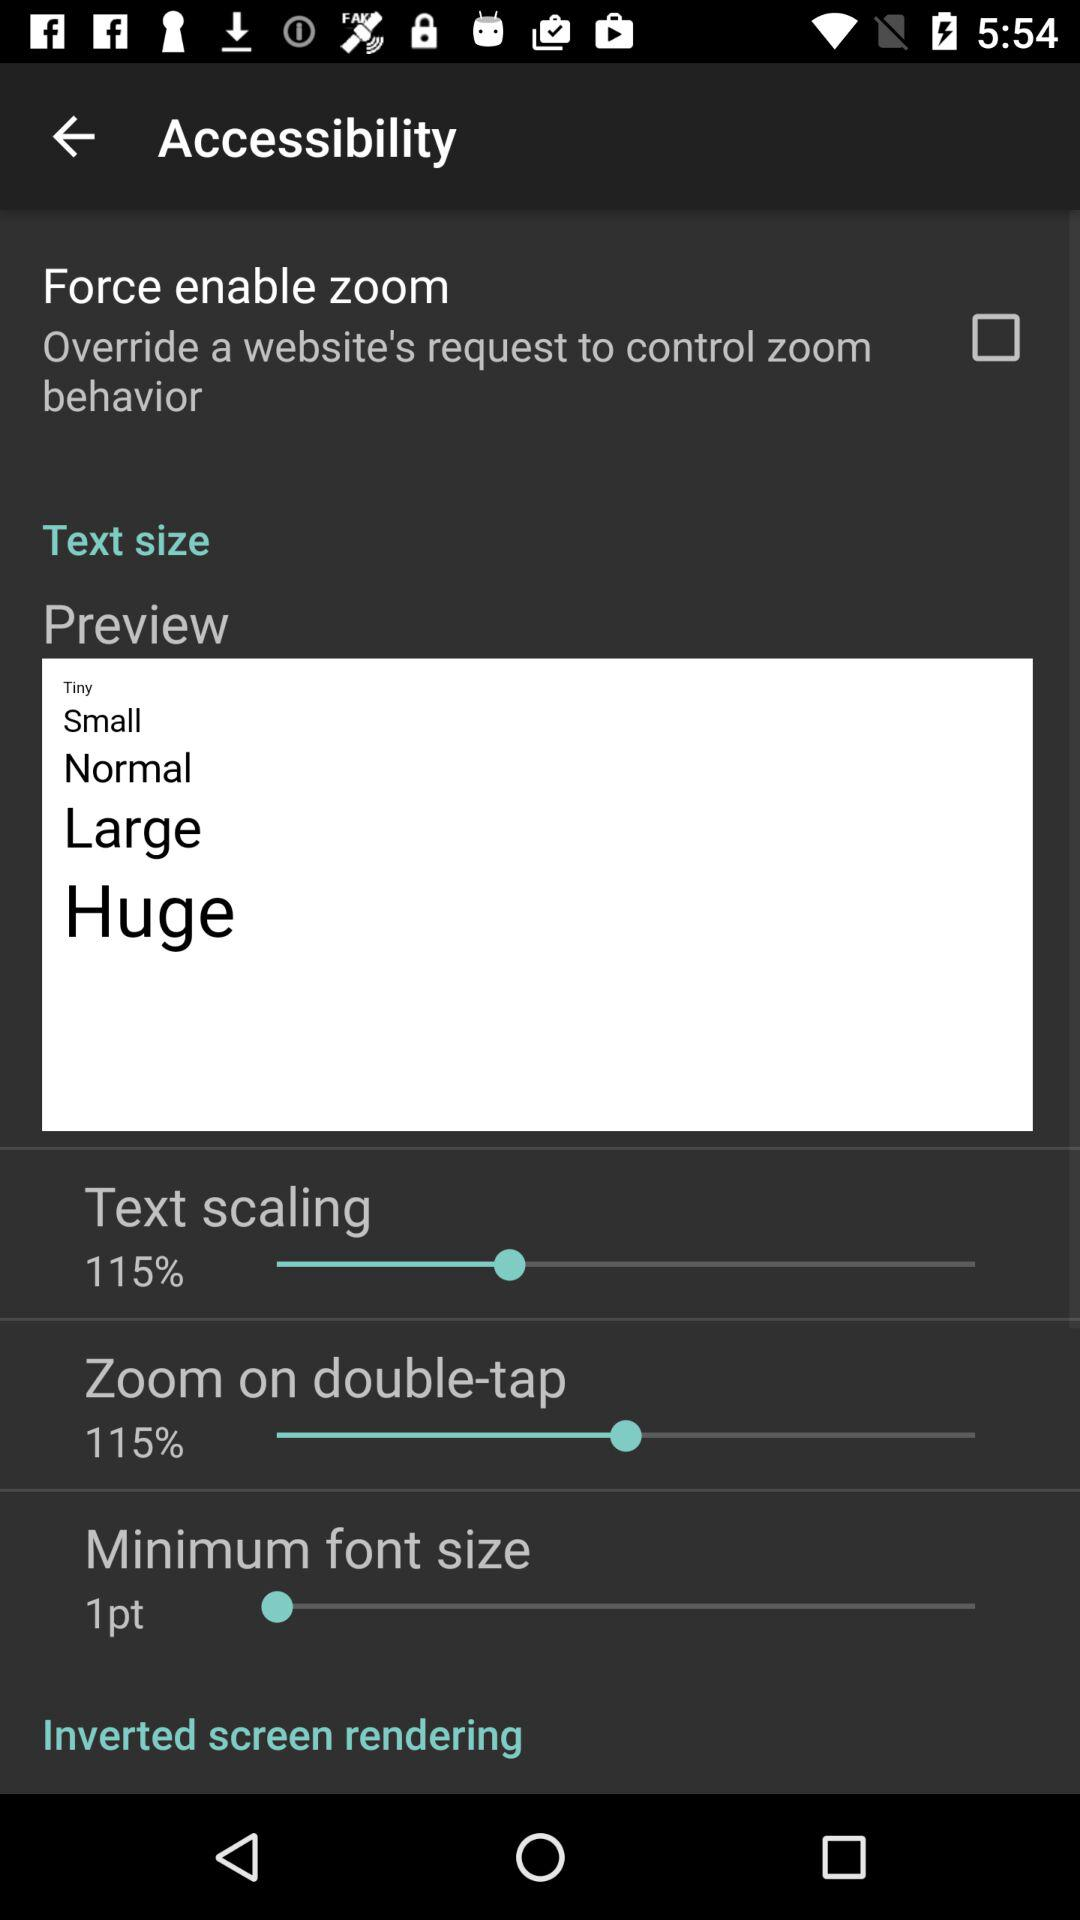How much is zoom?
Answer the question using a single word or phrase. Zoom is 115%. 